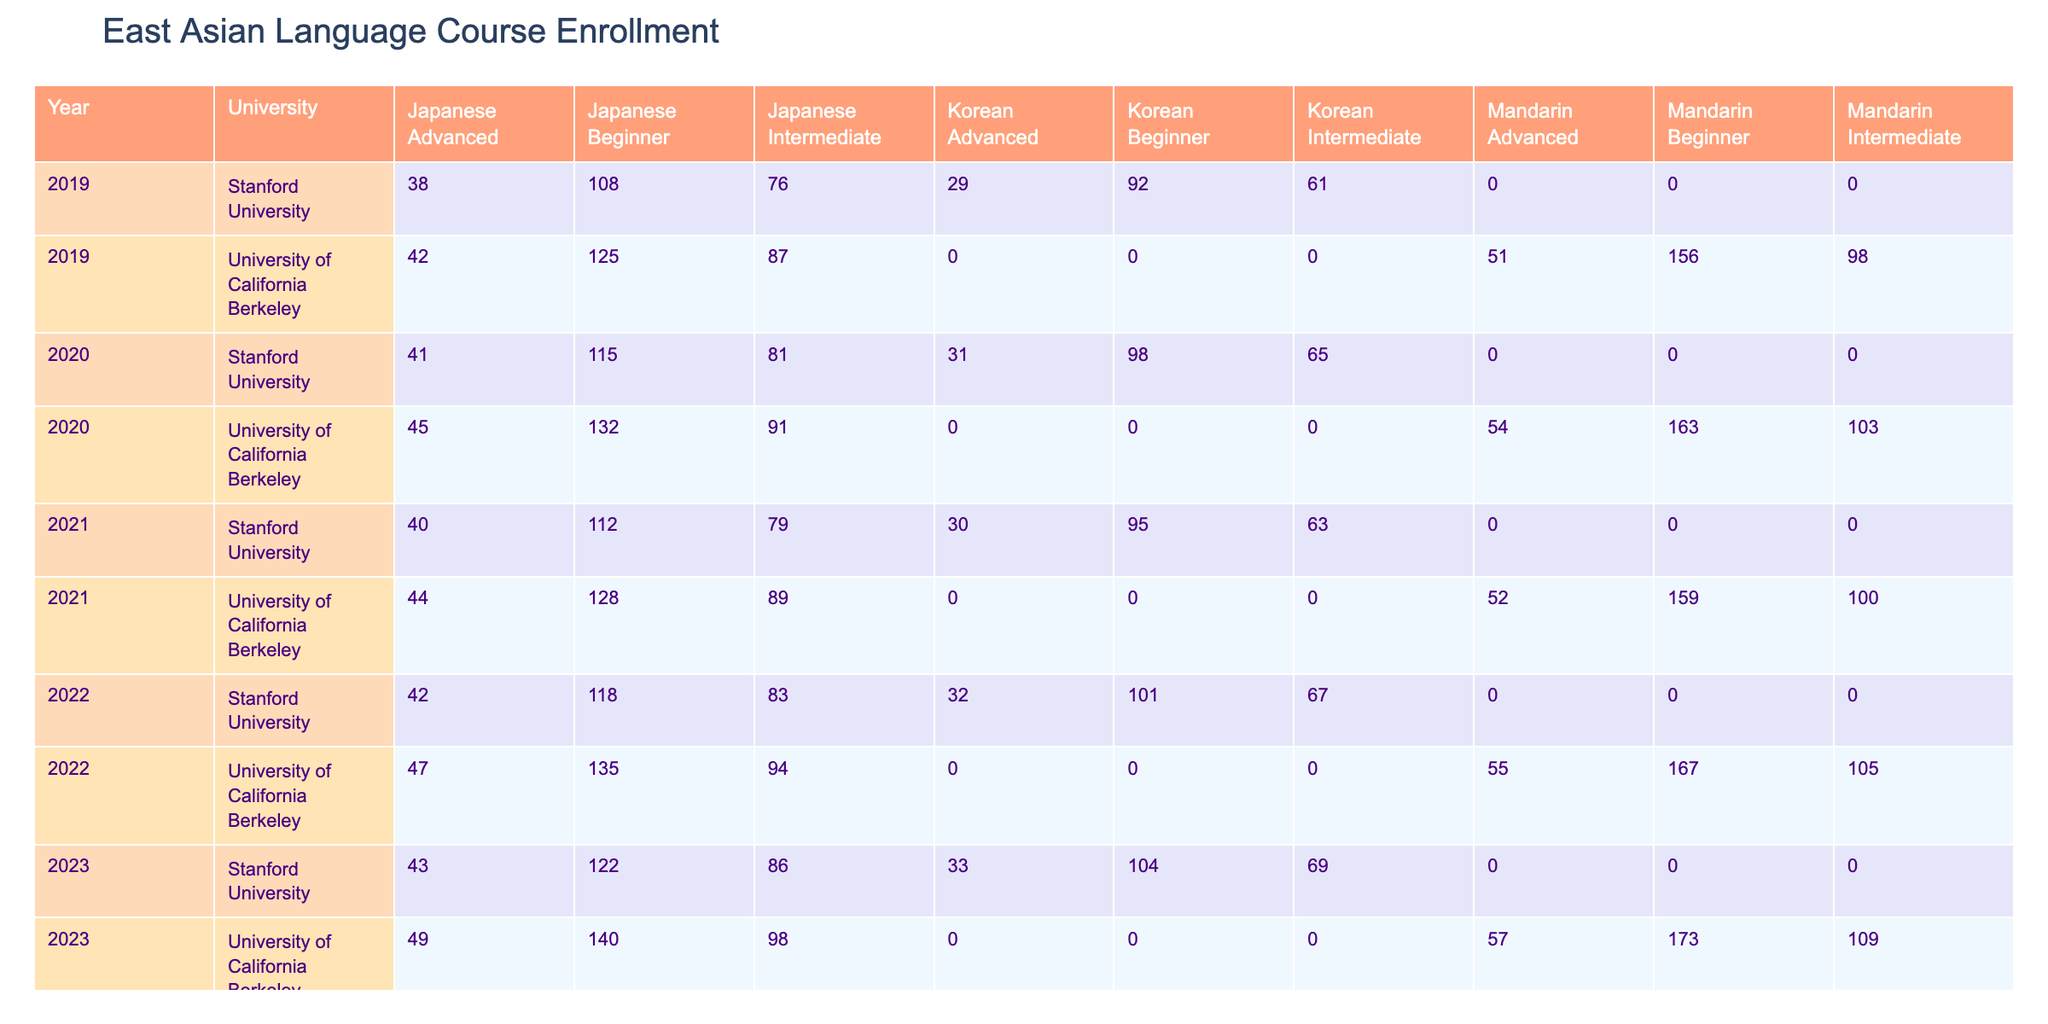What is the total enrollment for Beginner Japanese courses across both universities in 2023? To find the total enrollment for Beginner Japanese courses in 2023, I will look up the enrollment figures for both universities for Beginner Japanese specifically in the year 2023. At the University of California Berkeley, the enrollment is 140, and at Stanford University, it is 122. Adding these together gives 140 + 122 = 262.
Answer: 262 Which university had higher enrollment for Intermediate Mandarin courses in 2021? To determine which university had higher enrollment for Intermediate Mandarin courses in 2021, I check the specific value for both institutions. For the University of California Berkeley, the enrollment was 100, while for Stanford University it was not listed (meaning it was 0). Therefore, Berkeley had higher enrollment.
Answer: University of California Berkeley What was the average enrollment for Advanced Korean courses over the past 5 years? To calculate the average enrollment for Advanced Korean courses, I gather the total enrollment from each year from 2019 to 2023. The figures are: 29 in 2019, 31 in 2020, 30 in 2021, 32 in 2022, and 33 in 2023. Adding them gives 29 + 31 + 30 + 32 + 33 = 155. The average is then 155 divided by 5, which equals 31.
Answer: 31 Did the enrollment for Beginner Mandarin increase every year from 2019 to 2023? I will review the Beginner Mandarin enrollment figures for each year from 2019 to 2023. The enrollments are: 156 in 2019, 163 in 2020, 159 in 2021, 167 in 2022, and 173 in 2023. While there was a drop from 2021 to 2022, the overall trend shows increases in every other year. Therefore, the statement is false.
Answer: No What was the percentage increase in enrollment for Intermediate Japanese courses at Stanford University from 2019 to 2023? First, I locate the enrollment figures for Intermediate Japanese at Stanford for the given years: 76 in 2019 and 86 in 2023. To find the percentage increase, I use the formula: ((new value - old value) / old value) * 100. The calculation is ((86 - 76) / 76) * 100, which equals a percentage increase of approximately 13.16%.
Answer: Approximately 13.16% 